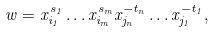Convert formula to latex. <formula><loc_0><loc_0><loc_500><loc_500>w = x _ { i _ { 1 } } ^ { s _ { 1 } } \dots x _ { i _ { m } } ^ { s _ { m } } x _ { j _ { n } } ^ { - t _ { n } } \dots x _ { j _ { 1 } } ^ { - t _ { 1 } } ,</formula> 